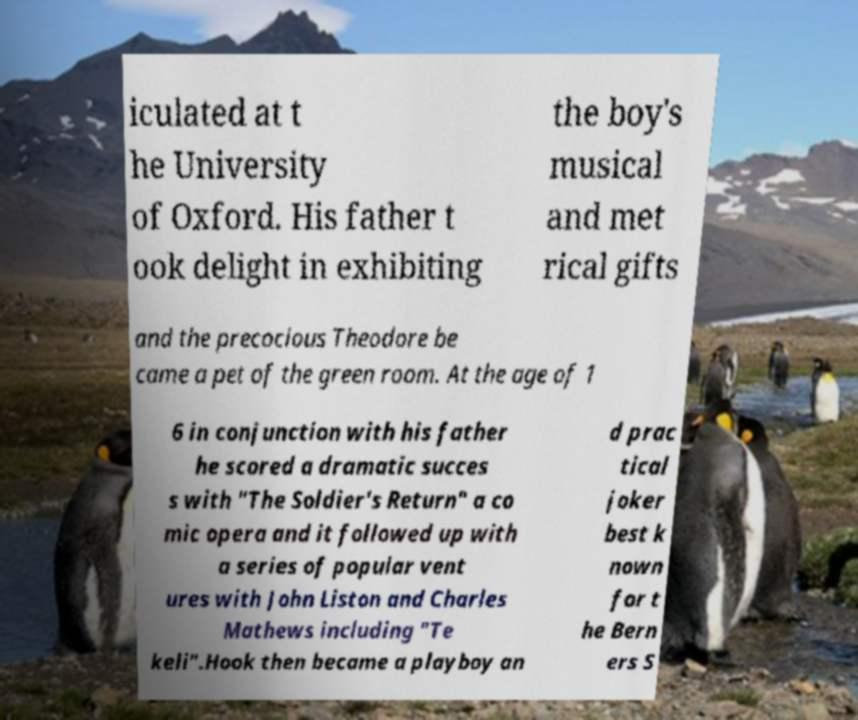For documentation purposes, I need the text within this image transcribed. Could you provide that? iculated at t he University of Oxford. His father t ook delight in exhibiting the boy's musical and met rical gifts and the precocious Theodore be came a pet of the green room. At the age of 1 6 in conjunction with his father he scored a dramatic succes s with "The Soldier's Return" a co mic opera and it followed up with a series of popular vent ures with John Liston and Charles Mathews including "Te keli".Hook then became a playboy an d prac tical joker best k nown for t he Bern ers S 